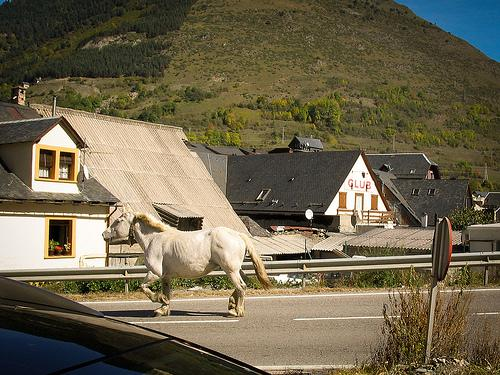Question: where is this picture taken?
Choices:
A. In a house.
B. At a restaurant.
C. This picture is taken on the street.
D. In a park.
Answer with the letter. Answer: C Question: what color is the animal in the picture?
Choices:
A. The animal is grey.
B. The animal is white.
C. The animal is black.
D. The animal is brown.
Answer with the letter. Answer: B Question: why is the animal on the street?
Choices:
A. It is in a parade.
B. It is a police animal.
C. Because the animal is running loose.
D. It is a seeing eye dog.
Answer with the letter. Answer: C Question: who is in the picture?
Choices:
A. Elephants.
B. Nobody is in the picture but a big animal.
C. Bears.
D. Zebras.
Answer with the letter. Answer: B 